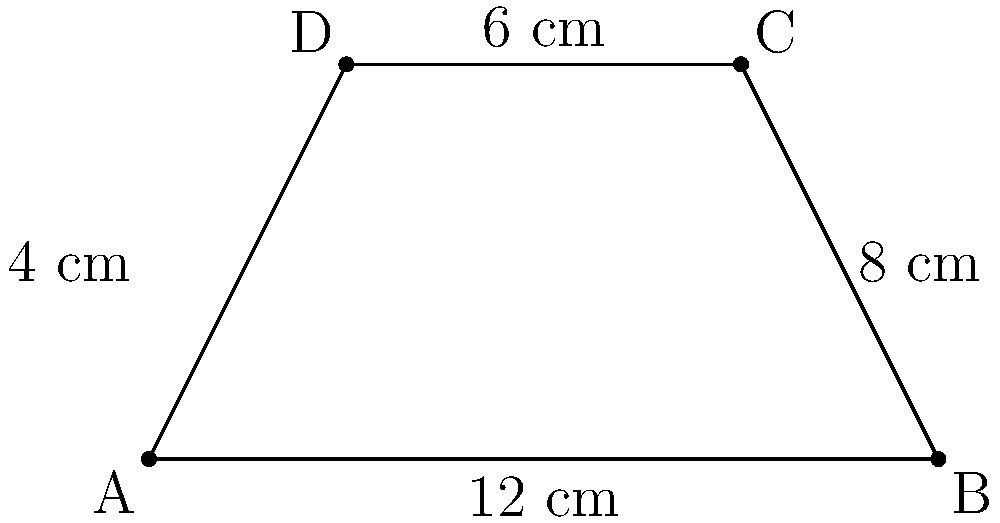You're designing a limited-edition Vera Wang-inspired trapezoidal handbag. The base of the handbag measures 12 cm, the top measures 6 cm, and the height is 4 cm. What is the area of the handbag's face in square centimeters? To find the area of a trapezoid, we use the formula:

$$A = \frac{1}{2}(b_1 + b_2)h$$

Where:
$A$ = Area
$b_1$ = Length of one parallel side
$b_2$ = Length of the other parallel side
$h$ = Height of the trapezoid

Given:
$b_1 = 12$ cm (base)
$b_2 = 6$ cm (top)
$h = 4$ cm (height)

Let's substitute these values into the formula:

$$A = \frac{1}{2}(12 + 6) \times 4$$

$$A = \frac{1}{2}(18) \times 4$$

$$A = 9 \times 4$$

$$A = 36$$

Therefore, the area of the handbag's face is 36 square centimeters.
Answer: 36 cm² 